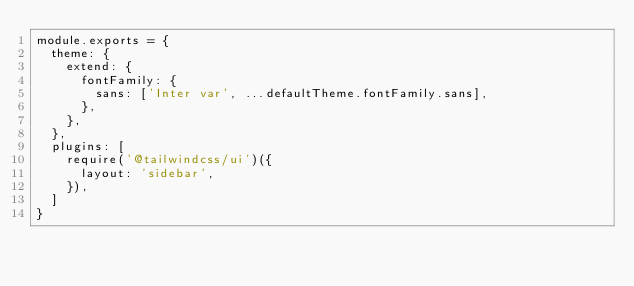<code> <loc_0><loc_0><loc_500><loc_500><_JavaScript_>module.exports = {
  theme: {
    extend: {
      fontFamily: {
        sans: ['Inter var', ...defaultTheme.fontFamily.sans],
      },
    },
  },
  plugins: [
    require('@tailwindcss/ui')({
      layout: 'sidebar',
    }),
  ]
}</code> 